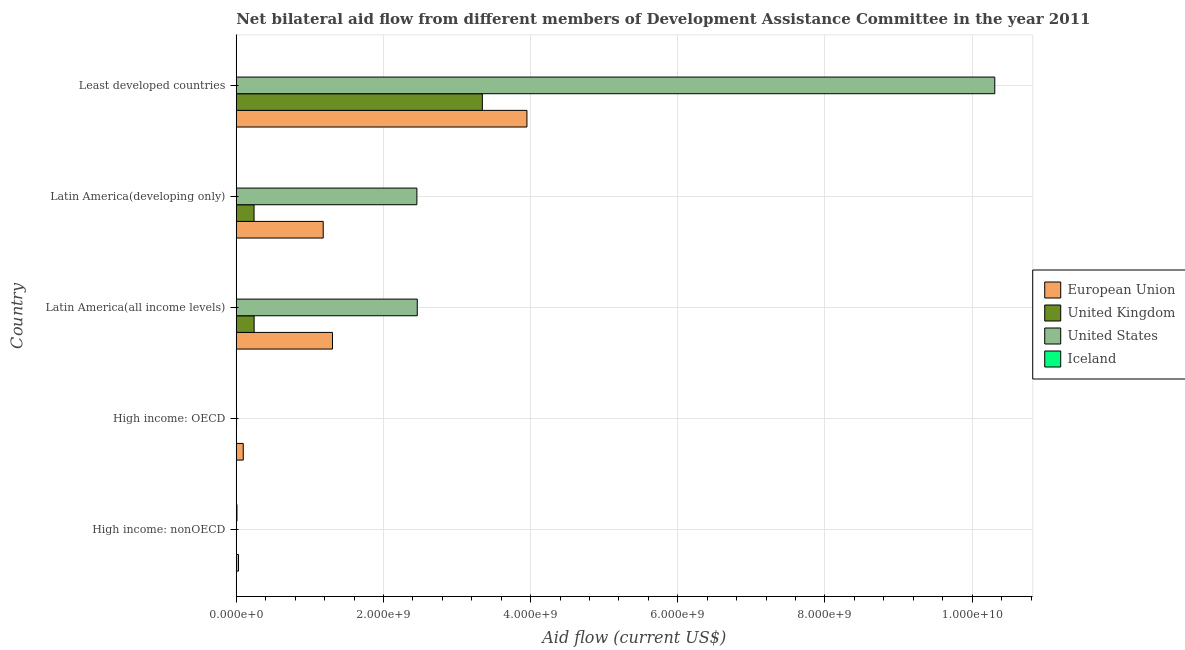Are the number of bars per tick equal to the number of legend labels?
Offer a terse response. Yes. What is the label of the 2nd group of bars from the top?
Offer a very short reply. Latin America(developing only). What is the amount of aid given by iceland in Latin America(all income levels)?
Give a very brief answer. 9.70e+05. Across all countries, what is the maximum amount of aid given by eu?
Offer a very short reply. 3.95e+09. Across all countries, what is the minimum amount of aid given by iceland?
Keep it short and to the point. 9.70e+05. In which country was the amount of aid given by eu maximum?
Offer a terse response. Least developed countries. In which country was the amount of aid given by eu minimum?
Your answer should be compact. High income: nonOECD. What is the total amount of aid given by us in the graph?
Ensure brevity in your answer.  1.52e+1. What is the difference between the amount of aid given by eu in High income: OECD and that in Latin America(developing only)?
Offer a very short reply. -1.09e+09. What is the difference between the amount of aid given by iceland in High income: nonOECD and the amount of aid given by eu in Latin America(all income levels)?
Make the answer very short. -1.30e+09. What is the average amount of aid given by eu per country?
Ensure brevity in your answer.  1.31e+09. What is the difference between the amount of aid given by eu and amount of aid given by uk in High income: OECD?
Offer a terse response. 9.44e+07. What is the ratio of the amount of aid given by eu in High income: OECD to that in High income: nonOECD?
Ensure brevity in your answer.  3.1. Is the amount of aid given by eu in High income: OECD less than that in Latin America(all income levels)?
Keep it short and to the point. Yes. What is the difference between the highest and the second highest amount of aid given by iceland?
Your answer should be very brief. 7.40e+06. What is the difference between the highest and the lowest amount of aid given by iceland?
Keep it short and to the point. 8.84e+06. In how many countries, is the amount of aid given by iceland greater than the average amount of aid given by iceland taken over all countries?
Your answer should be very brief. 1. Is it the case that in every country, the sum of the amount of aid given by eu and amount of aid given by us is greater than the sum of amount of aid given by uk and amount of aid given by iceland?
Keep it short and to the point. Yes. Is it the case that in every country, the sum of the amount of aid given by eu and amount of aid given by uk is greater than the amount of aid given by us?
Your answer should be compact. No. How many bars are there?
Your answer should be compact. 20. Are all the bars in the graph horizontal?
Provide a succinct answer. Yes. Are the values on the major ticks of X-axis written in scientific E-notation?
Provide a succinct answer. Yes. Does the graph contain grids?
Provide a succinct answer. Yes. Where does the legend appear in the graph?
Keep it short and to the point. Center right. How are the legend labels stacked?
Ensure brevity in your answer.  Vertical. What is the title of the graph?
Your answer should be compact. Net bilateral aid flow from different members of Development Assistance Committee in the year 2011. What is the Aid flow (current US$) of European Union in High income: nonOECD?
Offer a terse response. 3.07e+07. What is the Aid flow (current US$) in United Kingdom in High income: nonOECD?
Provide a succinct answer. 1.00e+05. What is the Aid flow (current US$) of United States in High income: nonOECD?
Give a very brief answer. 1.41e+06. What is the Aid flow (current US$) of Iceland in High income: nonOECD?
Make the answer very short. 9.81e+06. What is the Aid flow (current US$) in European Union in High income: OECD?
Your answer should be very brief. 9.50e+07. What is the Aid flow (current US$) of United Kingdom in High income: OECD?
Offer a terse response. 5.50e+05. What is the Aid flow (current US$) in United States in High income: OECD?
Give a very brief answer. 3.89e+06. What is the Aid flow (current US$) of Iceland in High income: OECD?
Your answer should be compact. 1.72e+06. What is the Aid flow (current US$) of European Union in Latin America(all income levels)?
Offer a very short reply. 1.31e+09. What is the Aid flow (current US$) in United Kingdom in Latin America(all income levels)?
Keep it short and to the point. 2.43e+08. What is the Aid flow (current US$) in United States in Latin America(all income levels)?
Offer a terse response. 2.46e+09. What is the Aid flow (current US$) in Iceland in Latin America(all income levels)?
Your response must be concise. 9.70e+05. What is the Aid flow (current US$) of European Union in Latin America(developing only)?
Give a very brief answer. 1.18e+09. What is the Aid flow (current US$) in United Kingdom in Latin America(developing only)?
Make the answer very short. 2.42e+08. What is the Aid flow (current US$) in United States in Latin America(developing only)?
Provide a short and direct response. 2.45e+09. What is the Aid flow (current US$) of Iceland in Latin America(developing only)?
Ensure brevity in your answer.  9.70e+05. What is the Aid flow (current US$) in European Union in Least developed countries?
Offer a very short reply. 3.95e+09. What is the Aid flow (current US$) in United Kingdom in Least developed countries?
Provide a short and direct response. 3.34e+09. What is the Aid flow (current US$) in United States in Least developed countries?
Ensure brevity in your answer.  1.03e+1. What is the Aid flow (current US$) in Iceland in Least developed countries?
Keep it short and to the point. 2.41e+06. Across all countries, what is the maximum Aid flow (current US$) of European Union?
Your response must be concise. 3.95e+09. Across all countries, what is the maximum Aid flow (current US$) of United Kingdom?
Ensure brevity in your answer.  3.34e+09. Across all countries, what is the maximum Aid flow (current US$) of United States?
Offer a very short reply. 1.03e+1. Across all countries, what is the maximum Aid flow (current US$) in Iceland?
Your answer should be compact. 9.81e+06. Across all countries, what is the minimum Aid flow (current US$) of European Union?
Your response must be concise. 3.07e+07. Across all countries, what is the minimum Aid flow (current US$) of United States?
Your answer should be very brief. 1.41e+06. Across all countries, what is the minimum Aid flow (current US$) in Iceland?
Your answer should be very brief. 9.70e+05. What is the total Aid flow (current US$) of European Union in the graph?
Your answer should be very brief. 6.56e+09. What is the total Aid flow (current US$) in United Kingdom in the graph?
Offer a very short reply. 3.83e+09. What is the total Aid flow (current US$) in United States in the graph?
Provide a succinct answer. 1.52e+1. What is the total Aid flow (current US$) in Iceland in the graph?
Keep it short and to the point. 1.59e+07. What is the difference between the Aid flow (current US$) of European Union in High income: nonOECD and that in High income: OECD?
Provide a short and direct response. -6.43e+07. What is the difference between the Aid flow (current US$) in United Kingdom in High income: nonOECD and that in High income: OECD?
Your answer should be very brief. -4.50e+05. What is the difference between the Aid flow (current US$) in United States in High income: nonOECD and that in High income: OECD?
Make the answer very short. -2.48e+06. What is the difference between the Aid flow (current US$) of Iceland in High income: nonOECD and that in High income: OECD?
Your response must be concise. 8.09e+06. What is the difference between the Aid flow (current US$) in European Union in High income: nonOECD and that in Latin America(all income levels)?
Make the answer very short. -1.28e+09. What is the difference between the Aid flow (current US$) in United Kingdom in High income: nonOECD and that in Latin America(all income levels)?
Make the answer very short. -2.43e+08. What is the difference between the Aid flow (current US$) of United States in High income: nonOECD and that in Latin America(all income levels)?
Ensure brevity in your answer.  -2.46e+09. What is the difference between the Aid flow (current US$) in Iceland in High income: nonOECD and that in Latin America(all income levels)?
Make the answer very short. 8.84e+06. What is the difference between the Aid flow (current US$) of European Union in High income: nonOECD and that in Latin America(developing only)?
Keep it short and to the point. -1.15e+09. What is the difference between the Aid flow (current US$) of United Kingdom in High income: nonOECD and that in Latin America(developing only)?
Ensure brevity in your answer.  -2.42e+08. What is the difference between the Aid flow (current US$) of United States in High income: nonOECD and that in Latin America(developing only)?
Your answer should be very brief. -2.45e+09. What is the difference between the Aid flow (current US$) of Iceland in High income: nonOECD and that in Latin America(developing only)?
Offer a very short reply. 8.84e+06. What is the difference between the Aid flow (current US$) of European Union in High income: nonOECD and that in Least developed countries?
Make the answer very short. -3.92e+09. What is the difference between the Aid flow (current US$) of United Kingdom in High income: nonOECD and that in Least developed countries?
Offer a terse response. -3.34e+09. What is the difference between the Aid flow (current US$) in United States in High income: nonOECD and that in Least developed countries?
Your answer should be very brief. -1.03e+1. What is the difference between the Aid flow (current US$) in Iceland in High income: nonOECD and that in Least developed countries?
Your answer should be very brief. 7.40e+06. What is the difference between the Aid flow (current US$) of European Union in High income: OECD and that in Latin America(all income levels)?
Your answer should be very brief. -1.21e+09. What is the difference between the Aid flow (current US$) in United Kingdom in High income: OECD and that in Latin America(all income levels)?
Your answer should be compact. -2.42e+08. What is the difference between the Aid flow (current US$) of United States in High income: OECD and that in Latin America(all income levels)?
Give a very brief answer. -2.46e+09. What is the difference between the Aid flow (current US$) of Iceland in High income: OECD and that in Latin America(all income levels)?
Keep it short and to the point. 7.50e+05. What is the difference between the Aid flow (current US$) of European Union in High income: OECD and that in Latin America(developing only)?
Make the answer very short. -1.09e+09. What is the difference between the Aid flow (current US$) of United Kingdom in High income: OECD and that in Latin America(developing only)?
Ensure brevity in your answer.  -2.41e+08. What is the difference between the Aid flow (current US$) in United States in High income: OECD and that in Latin America(developing only)?
Provide a short and direct response. -2.45e+09. What is the difference between the Aid flow (current US$) of Iceland in High income: OECD and that in Latin America(developing only)?
Offer a very short reply. 7.50e+05. What is the difference between the Aid flow (current US$) of European Union in High income: OECD and that in Least developed countries?
Your answer should be compact. -3.85e+09. What is the difference between the Aid flow (current US$) in United Kingdom in High income: OECD and that in Least developed countries?
Your answer should be very brief. -3.34e+09. What is the difference between the Aid flow (current US$) in United States in High income: OECD and that in Least developed countries?
Give a very brief answer. -1.03e+1. What is the difference between the Aid flow (current US$) in Iceland in High income: OECD and that in Least developed countries?
Offer a terse response. -6.90e+05. What is the difference between the Aid flow (current US$) of European Union in Latin America(all income levels) and that in Latin America(developing only)?
Offer a very short reply. 1.26e+08. What is the difference between the Aid flow (current US$) of United Kingdom in Latin America(all income levels) and that in Latin America(developing only)?
Make the answer very short. 1.04e+06. What is the difference between the Aid flow (current US$) of United States in Latin America(all income levels) and that in Latin America(developing only)?
Keep it short and to the point. 5.25e+06. What is the difference between the Aid flow (current US$) in European Union in Latin America(all income levels) and that in Least developed countries?
Provide a succinct answer. -2.64e+09. What is the difference between the Aid flow (current US$) in United Kingdom in Latin America(all income levels) and that in Least developed countries?
Your answer should be very brief. -3.10e+09. What is the difference between the Aid flow (current US$) in United States in Latin America(all income levels) and that in Least developed countries?
Make the answer very short. -7.85e+09. What is the difference between the Aid flow (current US$) in Iceland in Latin America(all income levels) and that in Least developed countries?
Ensure brevity in your answer.  -1.44e+06. What is the difference between the Aid flow (current US$) in European Union in Latin America(developing only) and that in Least developed countries?
Offer a very short reply. -2.77e+09. What is the difference between the Aid flow (current US$) of United Kingdom in Latin America(developing only) and that in Least developed countries?
Give a very brief answer. -3.10e+09. What is the difference between the Aid flow (current US$) of United States in Latin America(developing only) and that in Least developed countries?
Your response must be concise. -7.85e+09. What is the difference between the Aid flow (current US$) of Iceland in Latin America(developing only) and that in Least developed countries?
Keep it short and to the point. -1.44e+06. What is the difference between the Aid flow (current US$) in European Union in High income: nonOECD and the Aid flow (current US$) in United Kingdom in High income: OECD?
Provide a short and direct response. 3.01e+07. What is the difference between the Aid flow (current US$) of European Union in High income: nonOECD and the Aid flow (current US$) of United States in High income: OECD?
Ensure brevity in your answer.  2.68e+07. What is the difference between the Aid flow (current US$) in European Union in High income: nonOECD and the Aid flow (current US$) in Iceland in High income: OECD?
Keep it short and to the point. 2.90e+07. What is the difference between the Aid flow (current US$) in United Kingdom in High income: nonOECD and the Aid flow (current US$) in United States in High income: OECD?
Provide a succinct answer. -3.79e+06. What is the difference between the Aid flow (current US$) in United Kingdom in High income: nonOECD and the Aid flow (current US$) in Iceland in High income: OECD?
Your answer should be very brief. -1.62e+06. What is the difference between the Aid flow (current US$) in United States in High income: nonOECD and the Aid flow (current US$) in Iceland in High income: OECD?
Keep it short and to the point. -3.10e+05. What is the difference between the Aid flow (current US$) of European Union in High income: nonOECD and the Aid flow (current US$) of United Kingdom in Latin America(all income levels)?
Keep it short and to the point. -2.12e+08. What is the difference between the Aid flow (current US$) in European Union in High income: nonOECD and the Aid flow (current US$) in United States in Latin America(all income levels)?
Your answer should be compact. -2.43e+09. What is the difference between the Aid flow (current US$) in European Union in High income: nonOECD and the Aid flow (current US$) in Iceland in Latin America(all income levels)?
Provide a succinct answer. 2.97e+07. What is the difference between the Aid flow (current US$) in United Kingdom in High income: nonOECD and the Aid flow (current US$) in United States in Latin America(all income levels)?
Keep it short and to the point. -2.46e+09. What is the difference between the Aid flow (current US$) in United Kingdom in High income: nonOECD and the Aid flow (current US$) in Iceland in Latin America(all income levels)?
Make the answer very short. -8.70e+05. What is the difference between the Aid flow (current US$) of United States in High income: nonOECD and the Aid flow (current US$) of Iceland in Latin America(all income levels)?
Your answer should be compact. 4.40e+05. What is the difference between the Aid flow (current US$) in European Union in High income: nonOECD and the Aid flow (current US$) in United Kingdom in Latin America(developing only)?
Give a very brief answer. -2.11e+08. What is the difference between the Aid flow (current US$) of European Union in High income: nonOECD and the Aid flow (current US$) of United States in Latin America(developing only)?
Provide a short and direct response. -2.42e+09. What is the difference between the Aid flow (current US$) in European Union in High income: nonOECD and the Aid flow (current US$) in Iceland in Latin America(developing only)?
Your answer should be compact. 2.97e+07. What is the difference between the Aid flow (current US$) in United Kingdom in High income: nonOECD and the Aid flow (current US$) in United States in Latin America(developing only)?
Offer a terse response. -2.45e+09. What is the difference between the Aid flow (current US$) in United Kingdom in High income: nonOECD and the Aid flow (current US$) in Iceland in Latin America(developing only)?
Ensure brevity in your answer.  -8.70e+05. What is the difference between the Aid flow (current US$) of European Union in High income: nonOECD and the Aid flow (current US$) of United Kingdom in Least developed countries?
Provide a short and direct response. -3.31e+09. What is the difference between the Aid flow (current US$) of European Union in High income: nonOECD and the Aid flow (current US$) of United States in Least developed countries?
Your response must be concise. -1.03e+1. What is the difference between the Aid flow (current US$) of European Union in High income: nonOECD and the Aid flow (current US$) of Iceland in Least developed countries?
Offer a terse response. 2.83e+07. What is the difference between the Aid flow (current US$) in United Kingdom in High income: nonOECD and the Aid flow (current US$) in United States in Least developed countries?
Provide a succinct answer. -1.03e+1. What is the difference between the Aid flow (current US$) of United Kingdom in High income: nonOECD and the Aid flow (current US$) of Iceland in Least developed countries?
Provide a short and direct response. -2.31e+06. What is the difference between the Aid flow (current US$) in European Union in High income: OECD and the Aid flow (current US$) in United Kingdom in Latin America(all income levels)?
Provide a succinct answer. -1.48e+08. What is the difference between the Aid flow (current US$) of European Union in High income: OECD and the Aid flow (current US$) of United States in Latin America(all income levels)?
Give a very brief answer. -2.36e+09. What is the difference between the Aid flow (current US$) in European Union in High income: OECD and the Aid flow (current US$) in Iceland in Latin America(all income levels)?
Ensure brevity in your answer.  9.40e+07. What is the difference between the Aid flow (current US$) in United Kingdom in High income: OECD and the Aid flow (current US$) in United States in Latin America(all income levels)?
Offer a terse response. -2.46e+09. What is the difference between the Aid flow (current US$) in United Kingdom in High income: OECD and the Aid flow (current US$) in Iceland in Latin America(all income levels)?
Your response must be concise. -4.20e+05. What is the difference between the Aid flow (current US$) in United States in High income: OECD and the Aid flow (current US$) in Iceland in Latin America(all income levels)?
Give a very brief answer. 2.92e+06. What is the difference between the Aid flow (current US$) of European Union in High income: OECD and the Aid flow (current US$) of United Kingdom in Latin America(developing only)?
Keep it short and to the point. -1.47e+08. What is the difference between the Aid flow (current US$) in European Union in High income: OECD and the Aid flow (current US$) in United States in Latin America(developing only)?
Offer a terse response. -2.36e+09. What is the difference between the Aid flow (current US$) of European Union in High income: OECD and the Aid flow (current US$) of Iceland in Latin America(developing only)?
Ensure brevity in your answer.  9.40e+07. What is the difference between the Aid flow (current US$) in United Kingdom in High income: OECD and the Aid flow (current US$) in United States in Latin America(developing only)?
Your answer should be very brief. -2.45e+09. What is the difference between the Aid flow (current US$) of United Kingdom in High income: OECD and the Aid flow (current US$) of Iceland in Latin America(developing only)?
Your response must be concise. -4.20e+05. What is the difference between the Aid flow (current US$) in United States in High income: OECD and the Aid flow (current US$) in Iceland in Latin America(developing only)?
Make the answer very short. 2.92e+06. What is the difference between the Aid flow (current US$) of European Union in High income: OECD and the Aid flow (current US$) of United Kingdom in Least developed countries?
Your answer should be very brief. -3.25e+09. What is the difference between the Aid flow (current US$) in European Union in High income: OECD and the Aid flow (current US$) in United States in Least developed countries?
Offer a terse response. -1.02e+1. What is the difference between the Aid flow (current US$) of European Union in High income: OECD and the Aid flow (current US$) of Iceland in Least developed countries?
Make the answer very short. 9.26e+07. What is the difference between the Aid flow (current US$) in United Kingdom in High income: OECD and the Aid flow (current US$) in United States in Least developed countries?
Provide a short and direct response. -1.03e+1. What is the difference between the Aid flow (current US$) of United Kingdom in High income: OECD and the Aid flow (current US$) of Iceland in Least developed countries?
Your answer should be compact. -1.86e+06. What is the difference between the Aid flow (current US$) of United States in High income: OECD and the Aid flow (current US$) of Iceland in Least developed countries?
Your answer should be compact. 1.48e+06. What is the difference between the Aid flow (current US$) in European Union in Latin America(all income levels) and the Aid flow (current US$) in United Kingdom in Latin America(developing only)?
Ensure brevity in your answer.  1.07e+09. What is the difference between the Aid flow (current US$) of European Union in Latin America(all income levels) and the Aid flow (current US$) of United States in Latin America(developing only)?
Make the answer very short. -1.15e+09. What is the difference between the Aid flow (current US$) of European Union in Latin America(all income levels) and the Aid flow (current US$) of Iceland in Latin America(developing only)?
Offer a terse response. 1.31e+09. What is the difference between the Aid flow (current US$) of United Kingdom in Latin America(all income levels) and the Aid flow (current US$) of United States in Latin America(developing only)?
Offer a very short reply. -2.21e+09. What is the difference between the Aid flow (current US$) of United Kingdom in Latin America(all income levels) and the Aid flow (current US$) of Iceland in Latin America(developing only)?
Your answer should be compact. 2.42e+08. What is the difference between the Aid flow (current US$) in United States in Latin America(all income levels) and the Aid flow (current US$) in Iceland in Latin America(developing only)?
Give a very brief answer. 2.46e+09. What is the difference between the Aid flow (current US$) in European Union in Latin America(all income levels) and the Aid flow (current US$) in United Kingdom in Least developed countries?
Offer a very short reply. -2.04e+09. What is the difference between the Aid flow (current US$) of European Union in Latin America(all income levels) and the Aid flow (current US$) of United States in Least developed countries?
Your answer should be compact. -9.00e+09. What is the difference between the Aid flow (current US$) in European Union in Latin America(all income levels) and the Aid flow (current US$) in Iceland in Least developed countries?
Keep it short and to the point. 1.30e+09. What is the difference between the Aid flow (current US$) in United Kingdom in Latin America(all income levels) and the Aid flow (current US$) in United States in Least developed countries?
Keep it short and to the point. -1.01e+1. What is the difference between the Aid flow (current US$) of United Kingdom in Latin America(all income levels) and the Aid flow (current US$) of Iceland in Least developed countries?
Make the answer very short. 2.40e+08. What is the difference between the Aid flow (current US$) of United States in Latin America(all income levels) and the Aid flow (current US$) of Iceland in Least developed countries?
Give a very brief answer. 2.46e+09. What is the difference between the Aid flow (current US$) of European Union in Latin America(developing only) and the Aid flow (current US$) of United Kingdom in Least developed countries?
Provide a short and direct response. -2.16e+09. What is the difference between the Aid flow (current US$) in European Union in Latin America(developing only) and the Aid flow (current US$) in United States in Least developed countries?
Your answer should be compact. -9.13e+09. What is the difference between the Aid flow (current US$) of European Union in Latin America(developing only) and the Aid flow (current US$) of Iceland in Least developed countries?
Your answer should be compact. 1.18e+09. What is the difference between the Aid flow (current US$) in United Kingdom in Latin America(developing only) and the Aid flow (current US$) in United States in Least developed countries?
Make the answer very short. -1.01e+1. What is the difference between the Aid flow (current US$) of United Kingdom in Latin America(developing only) and the Aid flow (current US$) of Iceland in Least developed countries?
Your answer should be very brief. 2.39e+08. What is the difference between the Aid flow (current US$) of United States in Latin America(developing only) and the Aid flow (current US$) of Iceland in Least developed countries?
Keep it short and to the point. 2.45e+09. What is the average Aid flow (current US$) in European Union per country?
Ensure brevity in your answer.  1.31e+09. What is the average Aid flow (current US$) in United Kingdom per country?
Ensure brevity in your answer.  7.66e+08. What is the average Aid flow (current US$) in United States per country?
Your response must be concise. 3.05e+09. What is the average Aid flow (current US$) in Iceland per country?
Your response must be concise. 3.18e+06. What is the difference between the Aid flow (current US$) of European Union and Aid flow (current US$) of United Kingdom in High income: nonOECD?
Provide a short and direct response. 3.06e+07. What is the difference between the Aid flow (current US$) of European Union and Aid flow (current US$) of United States in High income: nonOECD?
Your answer should be compact. 2.93e+07. What is the difference between the Aid flow (current US$) in European Union and Aid flow (current US$) in Iceland in High income: nonOECD?
Offer a terse response. 2.09e+07. What is the difference between the Aid flow (current US$) of United Kingdom and Aid flow (current US$) of United States in High income: nonOECD?
Give a very brief answer. -1.31e+06. What is the difference between the Aid flow (current US$) in United Kingdom and Aid flow (current US$) in Iceland in High income: nonOECD?
Give a very brief answer. -9.71e+06. What is the difference between the Aid flow (current US$) of United States and Aid flow (current US$) of Iceland in High income: nonOECD?
Make the answer very short. -8.40e+06. What is the difference between the Aid flow (current US$) in European Union and Aid flow (current US$) in United Kingdom in High income: OECD?
Your answer should be very brief. 9.44e+07. What is the difference between the Aid flow (current US$) of European Union and Aid flow (current US$) of United States in High income: OECD?
Your response must be concise. 9.11e+07. What is the difference between the Aid flow (current US$) in European Union and Aid flow (current US$) in Iceland in High income: OECD?
Provide a succinct answer. 9.33e+07. What is the difference between the Aid flow (current US$) in United Kingdom and Aid flow (current US$) in United States in High income: OECD?
Give a very brief answer. -3.34e+06. What is the difference between the Aid flow (current US$) in United Kingdom and Aid flow (current US$) in Iceland in High income: OECD?
Provide a succinct answer. -1.17e+06. What is the difference between the Aid flow (current US$) in United States and Aid flow (current US$) in Iceland in High income: OECD?
Your answer should be compact. 2.17e+06. What is the difference between the Aid flow (current US$) in European Union and Aid flow (current US$) in United Kingdom in Latin America(all income levels)?
Your answer should be compact. 1.06e+09. What is the difference between the Aid flow (current US$) of European Union and Aid flow (current US$) of United States in Latin America(all income levels)?
Provide a short and direct response. -1.15e+09. What is the difference between the Aid flow (current US$) in European Union and Aid flow (current US$) in Iceland in Latin America(all income levels)?
Ensure brevity in your answer.  1.31e+09. What is the difference between the Aid flow (current US$) in United Kingdom and Aid flow (current US$) in United States in Latin America(all income levels)?
Ensure brevity in your answer.  -2.22e+09. What is the difference between the Aid flow (current US$) of United Kingdom and Aid flow (current US$) of Iceland in Latin America(all income levels)?
Offer a very short reply. 2.42e+08. What is the difference between the Aid flow (current US$) in United States and Aid flow (current US$) in Iceland in Latin America(all income levels)?
Offer a terse response. 2.46e+09. What is the difference between the Aid flow (current US$) in European Union and Aid flow (current US$) in United Kingdom in Latin America(developing only)?
Keep it short and to the point. 9.40e+08. What is the difference between the Aid flow (current US$) in European Union and Aid flow (current US$) in United States in Latin America(developing only)?
Offer a terse response. -1.27e+09. What is the difference between the Aid flow (current US$) of European Union and Aid flow (current US$) of Iceland in Latin America(developing only)?
Provide a succinct answer. 1.18e+09. What is the difference between the Aid flow (current US$) in United Kingdom and Aid flow (current US$) in United States in Latin America(developing only)?
Give a very brief answer. -2.21e+09. What is the difference between the Aid flow (current US$) of United Kingdom and Aid flow (current US$) of Iceland in Latin America(developing only)?
Keep it short and to the point. 2.41e+08. What is the difference between the Aid flow (current US$) in United States and Aid flow (current US$) in Iceland in Latin America(developing only)?
Your response must be concise. 2.45e+09. What is the difference between the Aid flow (current US$) in European Union and Aid flow (current US$) in United Kingdom in Least developed countries?
Provide a short and direct response. 6.06e+08. What is the difference between the Aid flow (current US$) in European Union and Aid flow (current US$) in United States in Least developed countries?
Provide a succinct answer. -6.36e+09. What is the difference between the Aid flow (current US$) of European Union and Aid flow (current US$) of Iceland in Least developed countries?
Provide a short and direct response. 3.95e+09. What is the difference between the Aid flow (current US$) of United Kingdom and Aid flow (current US$) of United States in Least developed countries?
Provide a short and direct response. -6.96e+09. What is the difference between the Aid flow (current US$) in United Kingdom and Aid flow (current US$) in Iceland in Least developed countries?
Make the answer very short. 3.34e+09. What is the difference between the Aid flow (current US$) in United States and Aid flow (current US$) in Iceland in Least developed countries?
Offer a very short reply. 1.03e+1. What is the ratio of the Aid flow (current US$) in European Union in High income: nonOECD to that in High income: OECD?
Make the answer very short. 0.32. What is the ratio of the Aid flow (current US$) of United Kingdom in High income: nonOECD to that in High income: OECD?
Give a very brief answer. 0.18. What is the ratio of the Aid flow (current US$) in United States in High income: nonOECD to that in High income: OECD?
Provide a succinct answer. 0.36. What is the ratio of the Aid flow (current US$) in Iceland in High income: nonOECD to that in High income: OECD?
Provide a succinct answer. 5.7. What is the ratio of the Aid flow (current US$) in European Union in High income: nonOECD to that in Latin America(all income levels)?
Offer a very short reply. 0.02. What is the ratio of the Aid flow (current US$) in United Kingdom in High income: nonOECD to that in Latin America(all income levels)?
Your answer should be compact. 0. What is the ratio of the Aid flow (current US$) of United States in High income: nonOECD to that in Latin America(all income levels)?
Your answer should be very brief. 0. What is the ratio of the Aid flow (current US$) in Iceland in High income: nonOECD to that in Latin America(all income levels)?
Give a very brief answer. 10.11. What is the ratio of the Aid flow (current US$) in European Union in High income: nonOECD to that in Latin America(developing only)?
Provide a succinct answer. 0.03. What is the ratio of the Aid flow (current US$) of United States in High income: nonOECD to that in Latin America(developing only)?
Your answer should be compact. 0. What is the ratio of the Aid flow (current US$) of Iceland in High income: nonOECD to that in Latin America(developing only)?
Keep it short and to the point. 10.11. What is the ratio of the Aid flow (current US$) of European Union in High income: nonOECD to that in Least developed countries?
Your answer should be compact. 0.01. What is the ratio of the Aid flow (current US$) of United Kingdom in High income: nonOECD to that in Least developed countries?
Give a very brief answer. 0. What is the ratio of the Aid flow (current US$) of United States in High income: nonOECD to that in Least developed countries?
Give a very brief answer. 0. What is the ratio of the Aid flow (current US$) of Iceland in High income: nonOECD to that in Least developed countries?
Provide a short and direct response. 4.07. What is the ratio of the Aid flow (current US$) in European Union in High income: OECD to that in Latin America(all income levels)?
Keep it short and to the point. 0.07. What is the ratio of the Aid flow (current US$) of United Kingdom in High income: OECD to that in Latin America(all income levels)?
Your response must be concise. 0. What is the ratio of the Aid flow (current US$) of United States in High income: OECD to that in Latin America(all income levels)?
Keep it short and to the point. 0. What is the ratio of the Aid flow (current US$) of Iceland in High income: OECD to that in Latin America(all income levels)?
Your answer should be compact. 1.77. What is the ratio of the Aid flow (current US$) of European Union in High income: OECD to that in Latin America(developing only)?
Give a very brief answer. 0.08. What is the ratio of the Aid flow (current US$) of United Kingdom in High income: OECD to that in Latin America(developing only)?
Offer a very short reply. 0. What is the ratio of the Aid flow (current US$) in United States in High income: OECD to that in Latin America(developing only)?
Make the answer very short. 0. What is the ratio of the Aid flow (current US$) in Iceland in High income: OECD to that in Latin America(developing only)?
Your response must be concise. 1.77. What is the ratio of the Aid flow (current US$) in European Union in High income: OECD to that in Least developed countries?
Keep it short and to the point. 0.02. What is the ratio of the Aid flow (current US$) in United Kingdom in High income: OECD to that in Least developed countries?
Your answer should be very brief. 0. What is the ratio of the Aid flow (current US$) of United States in High income: OECD to that in Least developed countries?
Provide a succinct answer. 0. What is the ratio of the Aid flow (current US$) in Iceland in High income: OECD to that in Least developed countries?
Your answer should be very brief. 0.71. What is the ratio of the Aid flow (current US$) in European Union in Latin America(all income levels) to that in Latin America(developing only)?
Make the answer very short. 1.11. What is the ratio of the Aid flow (current US$) in Iceland in Latin America(all income levels) to that in Latin America(developing only)?
Keep it short and to the point. 1. What is the ratio of the Aid flow (current US$) of European Union in Latin America(all income levels) to that in Least developed countries?
Offer a very short reply. 0.33. What is the ratio of the Aid flow (current US$) of United Kingdom in Latin America(all income levels) to that in Least developed countries?
Ensure brevity in your answer.  0.07. What is the ratio of the Aid flow (current US$) of United States in Latin America(all income levels) to that in Least developed countries?
Offer a terse response. 0.24. What is the ratio of the Aid flow (current US$) of Iceland in Latin America(all income levels) to that in Least developed countries?
Keep it short and to the point. 0.4. What is the ratio of the Aid flow (current US$) of European Union in Latin America(developing only) to that in Least developed countries?
Offer a very short reply. 0.3. What is the ratio of the Aid flow (current US$) of United Kingdom in Latin America(developing only) to that in Least developed countries?
Offer a very short reply. 0.07. What is the ratio of the Aid flow (current US$) of United States in Latin America(developing only) to that in Least developed countries?
Offer a terse response. 0.24. What is the ratio of the Aid flow (current US$) of Iceland in Latin America(developing only) to that in Least developed countries?
Give a very brief answer. 0.4. What is the difference between the highest and the second highest Aid flow (current US$) in European Union?
Provide a short and direct response. 2.64e+09. What is the difference between the highest and the second highest Aid flow (current US$) of United Kingdom?
Provide a short and direct response. 3.10e+09. What is the difference between the highest and the second highest Aid flow (current US$) in United States?
Offer a terse response. 7.85e+09. What is the difference between the highest and the second highest Aid flow (current US$) in Iceland?
Make the answer very short. 7.40e+06. What is the difference between the highest and the lowest Aid flow (current US$) in European Union?
Offer a terse response. 3.92e+09. What is the difference between the highest and the lowest Aid flow (current US$) of United Kingdom?
Give a very brief answer. 3.34e+09. What is the difference between the highest and the lowest Aid flow (current US$) of United States?
Keep it short and to the point. 1.03e+1. What is the difference between the highest and the lowest Aid flow (current US$) of Iceland?
Your answer should be compact. 8.84e+06. 